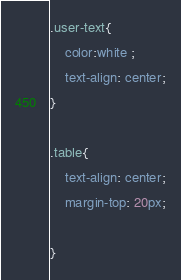Convert code to text. <code><loc_0><loc_0><loc_500><loc_500><_CSS_>

.user-text{
    color:white ;
    text-align: center;
}

.table{
    text-align: center;
    margin-top: 20px;
    
}



</code> 